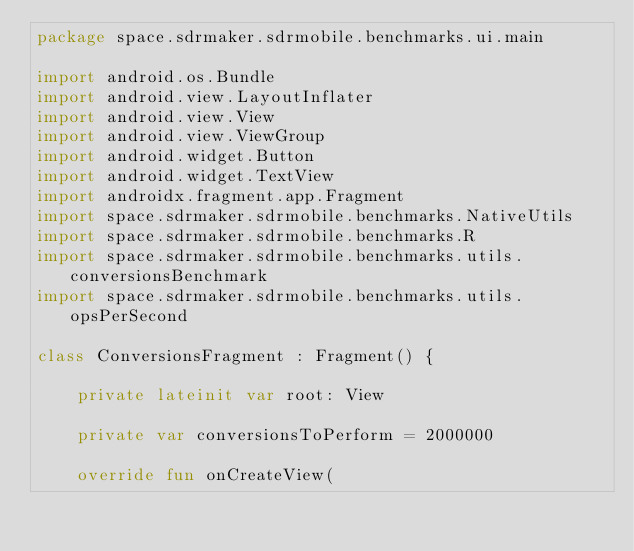<code> <loc_0><loc_0><loc_500><loc_500><_Kotlin_>package space.sdrmaker.sdrmobile.benchmarks.ui.main

import android.os.Bundle
import android.view.LayoutInflater
import android.view.View
import android.view.ViewGroup
import android.widget.Button
import android.widget.TextView
import androidx.fragment.app.Fragment
import space.sdrmaker.sdrmobile.benchmarks.NativeUtils
import space.sdrmaker.sdrmobile.benchmarks.R
import space.sdrmaker.sdrmobile.benchmarks.utils.conversionsBenchmark
import space.sdrmaker.sdrmobile.benchmarks.utils.opsPerSecond

class ConversionsFragment : Fragment() {

    private lateinit var root: View

    private var conversionsToPerform = 2000000

    override fun onCreateView(</code> 